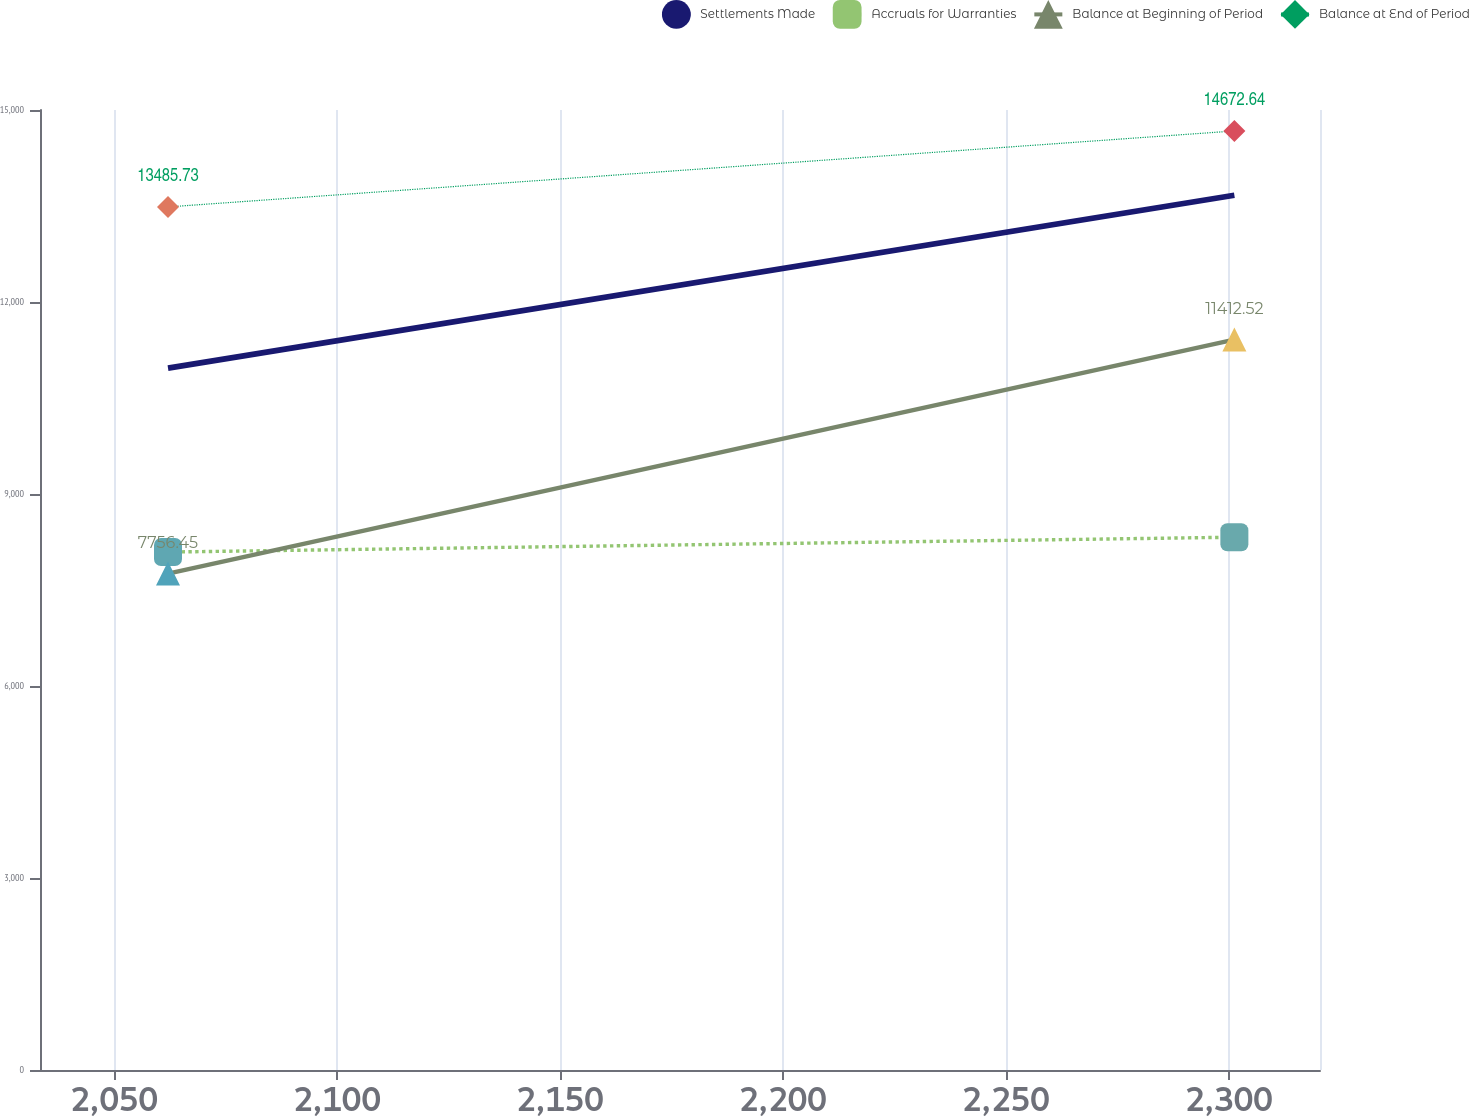Convert chart to OTSL. <chart><loc_0><loc_0><loc_500><loc_500><line_chart><ecel><fcel>Settlements Made<fcel>Accruals for Warranties<fcel>Balance at Beginning of Period<fcel>Balance at End of Period<nl><fcel>2062.09<fcel>10966.7<fcel>8092.83<fcel>7756.45<fcel>13485.7<nl><fcel>2301.24<fcel>13668.4<fcel>8324.83<fcel>11412.5<fcel>14672.6<nl><fcel>2349.15<fcel>11563.4<fcel>8852.9<fcel>9673.02<fcel>12569.7<nl></chart> 